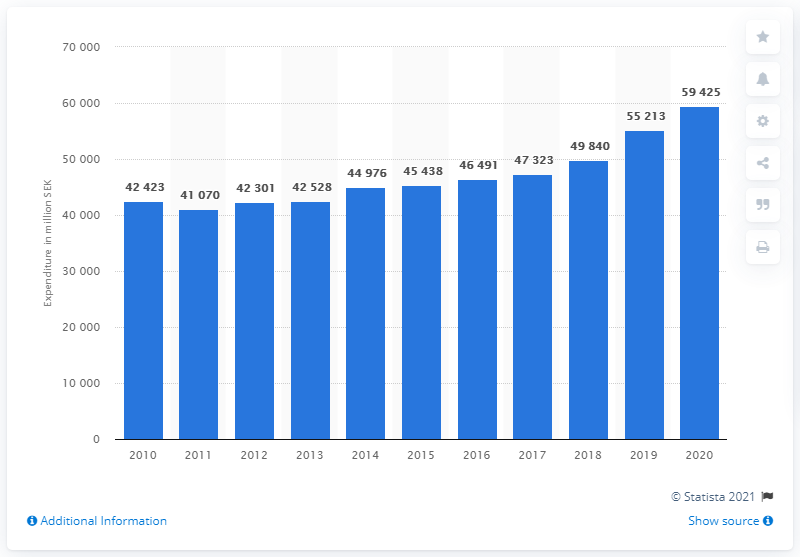Draw attention to some important aspects in this diagram. As of 2020, the highest amount of Swedish kronor was 59,425. 